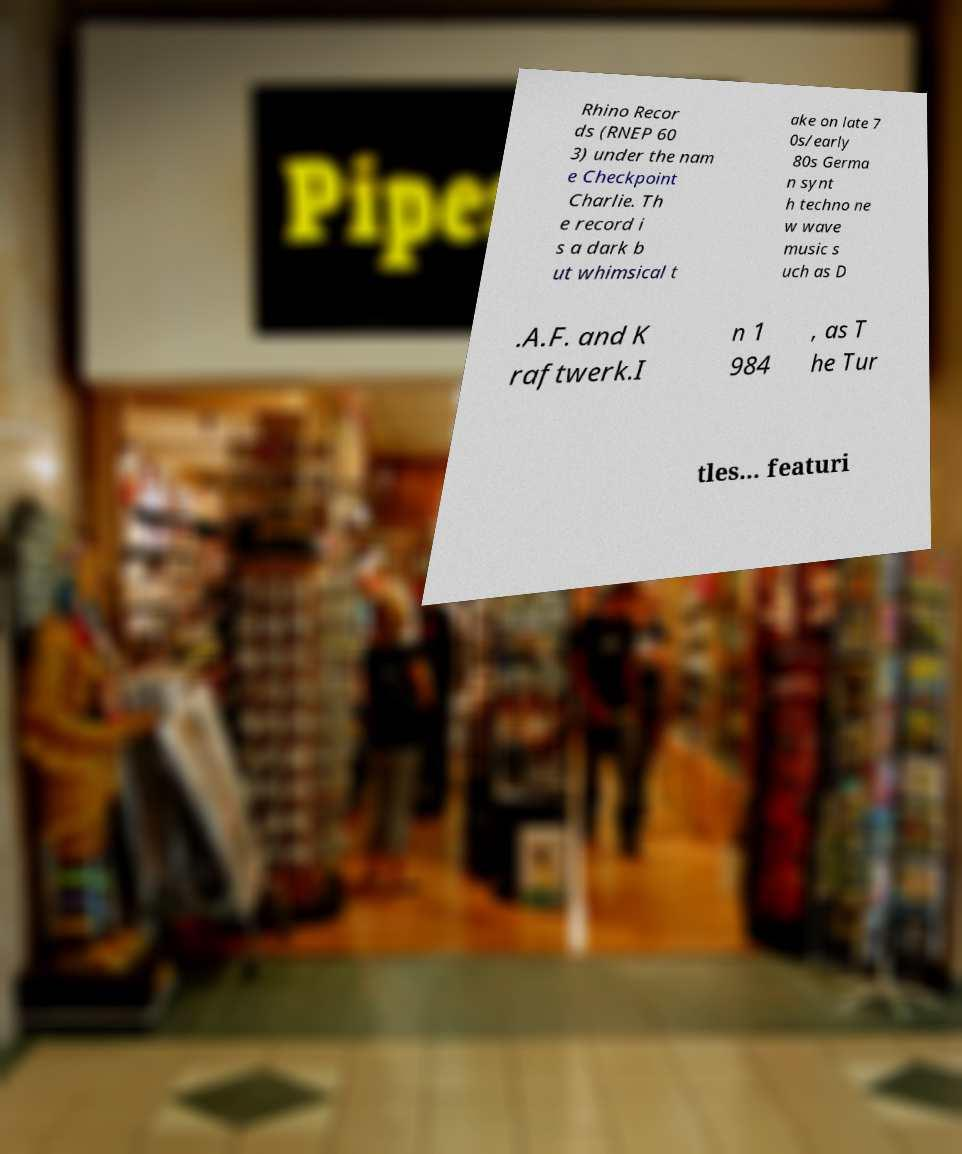Can you read and provide the text displayed in the image?This photo seems to have some interesting text. Can you extract and type it out for me? Rhino Recor ds (RNEP 60 3) under the nam e Checkpoint Charlie. Th e record i s a dark b ut whimsical t ake on late 7 0s/early 80s Germa n synt h techno ne w wave music s uch as D .A.F. and K raftwerk.I n 1 984 , as T he Tur tles... featuri 